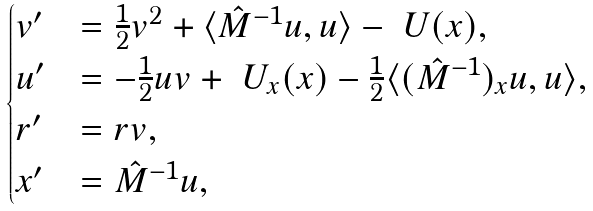<formula> <loc_0><loc_0><loc_500><loc_500>\begin{cases} v ^ { \prime } & = \frac { 1 } { 2 } v ^ { 2 } + \langle \hat { M } ^ { - 1 } u , u \rangle - \ U ( x ) , \\ u ^ { \prime } & = - \frac { 1 } { 2 } u v + \ U _ { x } ( x ) - \frac { 1 } { 2 } \langle ( \hat { M } ^ { - 1 } ) _ { x } u , u \rangle , \\ r ^ { \prime } & = r v , \\ x ^ { \prime } & = \hat { M } ^ { - 1 } u , \end{cases}</formula> 